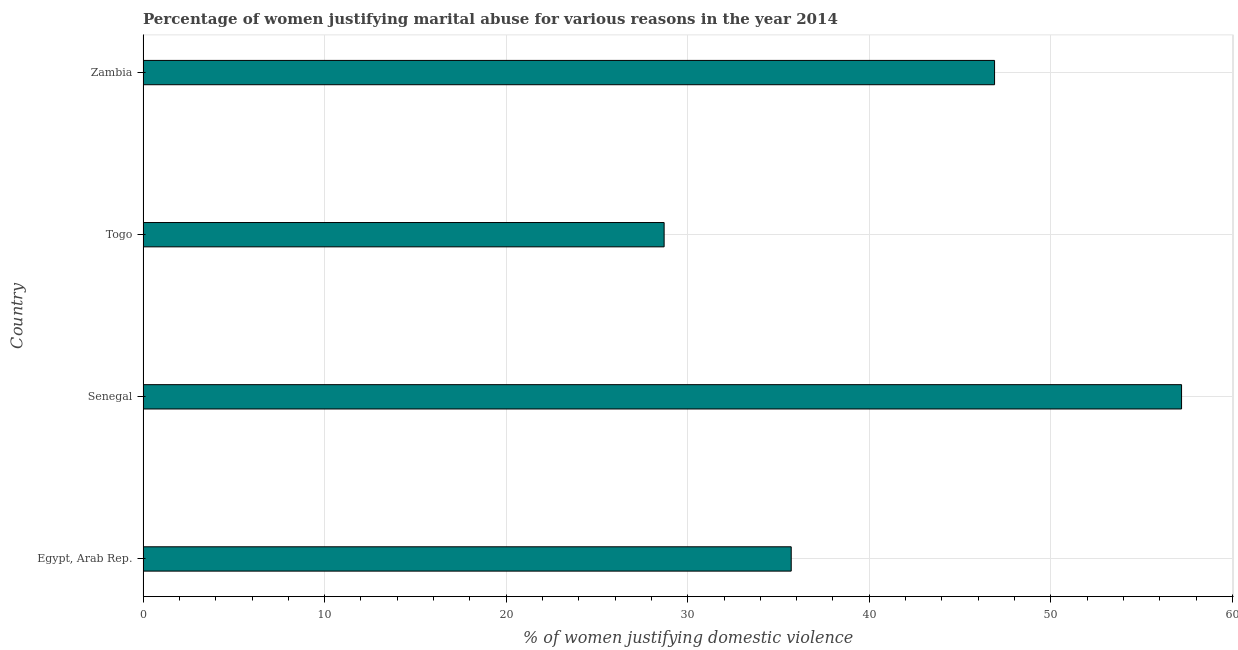Does the graph contain grids?
Your answer should be compact. Yes. What is the title of the graph?
Give a very brief answer. Percentage of women justifying marital abuse for various reasons in the year 2014. What is the label or title of the X-axis?
Provide a short and direct response. % of women justifying domestic violence. What is the percentage of women justifying marital abuse in Egypt, Arab Rep.?
Your answer should be compact. 35.7. Across all countries, what is the maximum percentage of women justifying marital abuse?
Make the answer very short. 57.2. Across all countries, what is the minimum percentage of women justifying marital abuse?
Your answer should be very brief. 28.7. In which country was the percentage of women justifying marital abuse maximum?
Your response must be concise. Senegal. In which country was the percentage of women justifying marital abuse minimum?
Offer a terse response. Togo. What is the sum of the percentage of women justifying marital abuse?
Provide a short and direct response. 168.5. What is the difference between the percentage of women justifying marital abuse in Togo and Zambia?
Make the answer very short. -18.2. What is the average percentage of women justifying marital abuse per country?
Provide a short and direct response. 42.12. What is the median percentage of women justifying marital abuse?
Your answer should be very brief. 41.3. What is the ratio of the percentage of women justifying marital abuse in Senegal to that in Zambia?
Your answer should be very brief. 1.22. Is the percentage of women justifying marital abuse in Senegal less than that in Togo?
Your answer should be very brief. No. Is the difference between the percentage of women justifying marital abuse in Egypt, Arab Rep. and Togo greater than the difference between any two countries?
Offer a very short reply. No. What is the difference between the highest and the second highest percentage of women justifying marital abuse?
Make the answer very short. 10.3. What is the difference between the highest and the lowest percentage of women justifying marital abuse?
Your answer should be compact. 28.5. In how many countries, is the percentage of women justifying marital abuse greater than the average percentage of women justifying marital abuse taken over all countries?
Offer a terse response. 2. Are all the bars in the graph horizontal?
Provide a short and direct response. Yes. What is the difference between two consecutive major ticks on the X-axis?
Provide a succinct answer. 10. Are the values on the major ticks of X-axis written in scientific E-notation?
Ensure brevity in your answer.  No. What is the % of women justifying domestic violence in Egypt, Arab Rep.?
Provide a succinct answer. 35.7. What is the % of women justifying domestic violence in Senegal?
Your answer should be compact. 57.2. What is the % of women justifying domestic violence of Togo?
Your answer should be compact. 28.7. What is the % of women justifying domestic violence of Zambia?
Keep it short and to the point. 46.9. What is the difference between the % of women justifying domestic violence in Egypt, Arab Rep. and Senegal?
Your answer should be very brief. -21.5. What is the difference between the % of women justifying domestic violence in Egypt, Arab Rep. and Togo?
Keep it short and to the point. 7. What is the difference between the % of women justifying domestic violence in Egypt, Arab Rep. and Zambia?
Your response must be concise. -11.2. What is the difference between the % of women justifying domestic violence in Togo and Zambia?
Give a very brief answer. -18.2. What is the ratio of the % of women justifying domestic violence in Egypt, Arab Rep. to that in Senegal?
Your answer should be compact. 0.62. What is the ratio of the % of women justifying domestic violence in Egypt, Arab Rep. to that in Togo?
Keep it short and to the point. 1.24. What is the ratio of the % of women justifying domestic violence in Egypt, Arab Rep. to that in Zambia?
Make the answer very short. 0.76. What is the ratio of the % of women justifying domestic violence in Senegal to that in Togo?
Give a very brief answer. 1.99. What is the ratio of the % of women justifying domestic violence in Senegal to that in Zambia?
Offer a terse response. 1.22. What is the ratio of the % of women justifying domestic violence in Togo to that in Zambia?
Make the answer very short. 0.61. 